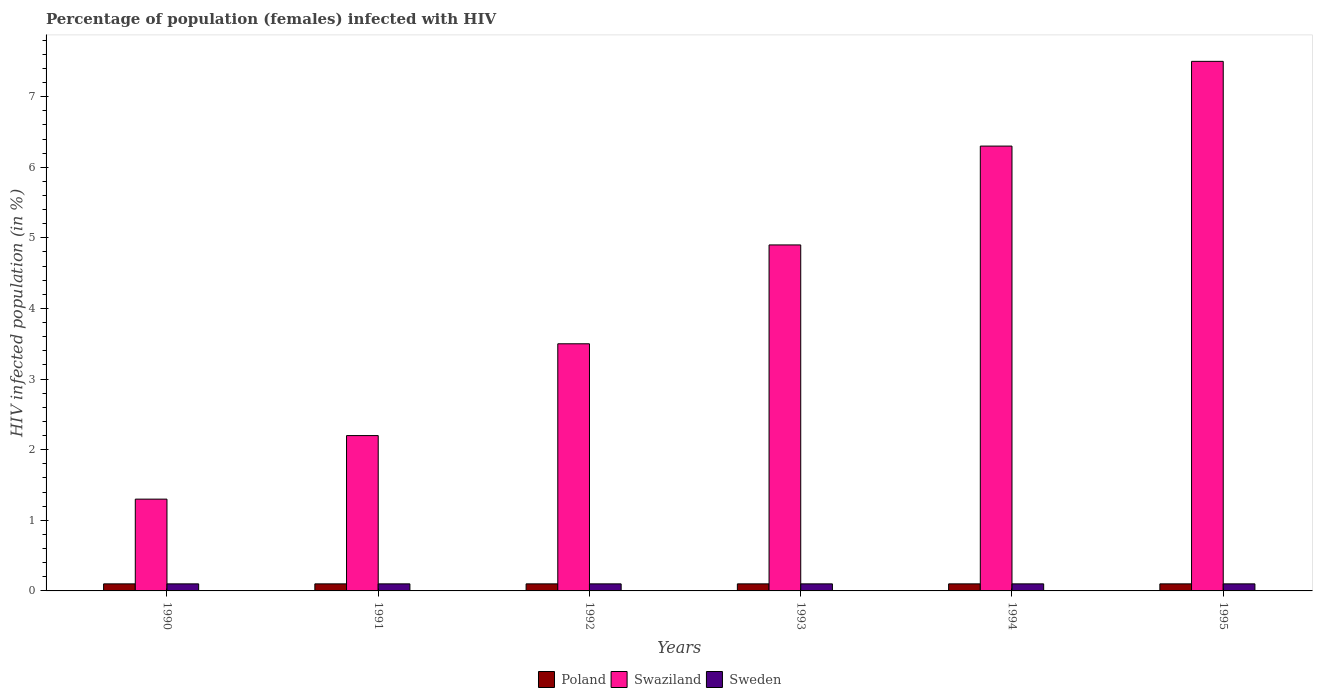How many groups of bars are there?
Give a very brief answer. 6. Are the number of bars per tick equal to the number of legend labels?
Keep it short and to the point. Yes. Are the number of bars on each tick of the X-axis equal?
Offer a very short reply. Yes. How many bars are there on the 1st tick from the left?
Your answer should be very brief. 3. How many bars are there on the 4th tick from the right?
Offer a terse response. 3. What is the label of the 5th group of bars from the left?
Your answer should be very brief. 1994. In how many cases, is the number of bars for a given year not equal to the number of legend labels?
Ensure brevity in your answer.  0. In which year was the percentage of HIV infected female population in Swaziland maximum?
Your answer should be compact. 1995. In which year was the percentage of HIV infected female population in Swaziland minimum?
Ensure brevity in your answer.  1990. What is the total percentage of HIV infected female population in Swaziland in the graph?
Your answer should be compact. 25.7. What is the average percentage of HIV infected female population in Sweden per year?
Provide a succinct answer. 0.1. In the year 1991, what is the difference between the percentage of HIV infected female population in Swaziland and percentage of HIV infected female population in Sweden?
Keep it short and to the point. 2.1. In how many years, is the percentage of HIV infected female population in Sweden greater than 7.6 %?
Offer a terse response. 0. Is the difference between the percentage of HIV infected female population in Swaziland in 1990 and 1992 greater than the difference between the percentage of HIV infected female population in Sweden in 1990 and 1992?
Provide a succinct answer. No. In how many years, is the percentage of HIV infected female population in Poland greater than the average percentage of HIV infected female population in Poland taken over all years?
Provide a short and direct response. 6. Is the sum of the percentage of HIV infected female population in Poland in 1992 and 1993 greater than the maximum percentage of HIV infected female population in Sweden across all years?
Make the answer very short. Yes. What does the 3rd bar from the left in 1992 represents?
Your answer should be compact. Sweden. What does the 3rd bar from the right in 1993 represents?
Provide a short and direct response. Poland. How many bars are there?
Your answer should be compact. 18. What is the difference between two consecutive major ticks on the Y-axis?
Your answer should be compact. 1. Does the graph contain any zero values?
Your answer should be compact. No. How are the legend labels stacked?
Your response must be concise. Horizontal. What is the title of the graph?
Your answer should be very brief. Percentage of population (females) infected with HIV. Does "South Africa" appear as one of the legend labels in the graph?
Keep it short and to the point. No. What is the label or title of the X-axis?
Offer a terse response. Years. What is the label or title of the Y-axis?
Offer a very short reply. HIV infected population (in %). What is the HIV infected population (in %) in Poland in 1990?
Your response must be concise. 0.1. What is the HIV infected population (in %) of Sweden in 1990?
Provide a short and direct response. 0.1. What is the HIV infected population (in %) in Poland in 1991?
Your response must be concise. 0.1. What is the HIV infected population (in %) in Sweden in 1991?
Your answer should be very brief. 0.1. What is the HIV infected population (in %) of Swaziland in 1992?
Ensure brevity in your answer.  3.5. What is the HIV infected population (in %) in Poland in 1993?
Provide a short and direct response. 0.1. What is the HIV infected population (in %) of Swaziland in 1993?
Give a very brief answer. 4.9. What is the HIV infected population (in %) of Sweden in 1993?
Your answer should be very brief. 0.1. What is the HIV infected population (in %) in Swaziland in 1994?
Provide a short and direct response. 6.3. Across all years, what is the maximum HIV infected population (in %) in Swaziland?
Give a very brief answer. 7.5. Across all years, what is the minimum HIV infected population (in %) of Swaziland?
Give a very brief answer. 1.3. Across all years, what is the minimum HIV infected population (in %) of Sweden?
Provide a succinct answer. 0.1. What is the total HIV infected population (in %) of Swaziland in the graph?
Provide a succinct answer. 25.7. What is the difference between the HIV infected population (in %) in Swaziland in 1990 and that in 1991?
Provide a succinct answer. -0.9. What is the difference between the HIV infected population (in %) in Sweden in 1990 and that in 1991?
Give a very brief answer. 0. What is the difference between the HIV infected population (in %) of Poland in 1990 and that in 1992?
Provide a succinct answer. 0. What is the difference between the HIV infected population (in %) of Sweden in 1990 and that in 1992?
Your answer should be very brief. 0. What is the difference between the HIV infected population (in %) of Swaziland in 1990 and that in 1993?
Keep it short and to the point. -3.6. What is the difference between the HIV infected population (in %) in Sweden in 1990 and that in 1993?
Your answer should be very brief. 0. What is the difference between the HIV infected population (in %) in Poland in 1990 and that in 1994?
Provide a succinct answer. 0. What is the difference between the HIV infected population (in %) in Sweden in 1990 and that in 1994?
Give a very brief answer. 0. What is the difference between the HIV infected population (in %) of Poland in 1990 and that in 1995?
Your answer should be very brief. 0. What is the difference between the HIV infected population (in %) in Swaziland in 1990 and that in 1995?
Give a very brief answer. -6.2. What is the difference between the HIV infected population (in %) of Swaziland in 1991 and that in 1992?
Keep it short and to the point. -1.3. What is the difference between the HIV infected population (in %) of Poland in 1991 and that in 1993?
Ensure brevity in your answer.  0. What is the difference between the HIV infected population (in %) of Sweden in 1991 and that in 1993?
Give a very brief answer. 0. What is the difference between the HIV infected population (in %) in Poland in 1991 and that in 1994?
Provide a succinct answer. 0. What is the difference between the HIV infected population (in %) in Sweden in 1991 and that in 1994?
Offer a terse response. 0. What is the difference between the HIV infected population (in %) of Poland in 1991 and that in 1995?
Keep it short and to the point. 0. What is the difference between the HIV infected population (in %) of Poland in 1992 and that in 1993?
Your response must be concise. 0. What is the difference between the HIV infected population (in %) in Poland in 1992 and that in 1994?
Provide a succinct answer. 0. What is the difference between the HIV infected population (in %) of Swaziland in 1992 and that in 1994?
Provide a short and direct response. -2.8. What is the difference between the HIV infected population (in %) in Sweden in 1992 and that in 1994?
Offer a terse response. 0. What is the difference between the HIV infected population (in %) in Poland in 1992 and that in 1995?
Offer a terse response. 0. What is the difference between the HIV infected population (in %) in Poland in 1993 and that in 1994?
Make the answer very short. 0. What is the difference between the HIV infected population (in %) in Swaziland in 1994 and that in 1995?
Your answer should be compact. -1.2. What is the difference between the HIV infected population (in %) of Poland in 1990 and the HIV infected population (in %) of Sweden in 1992?
Offer a very short reply. 0. What is the difference between the HIV infected population (in %) of Poland in 1990 and the HIV infected population (in %) of Sweden in 1993?
Give a very brief answer. 0. What is the difference between the HIV infected population (in %) of Poland in 1990 and the HIV infected population (in %) of Swaziland in 1994?
Your answer should be compact. -6.2. What is the difference between the HIV infected population (in %) in Swaziland in 1990 and the HIV infected population (in %) in Sweden in 1994?
Give a very brief answer. 1.2. What is the difference between the HIV infected population (in %) in Poland in 1990 and the HIV infected population (in %) in Swaziland in 1995?
Make the answer very short. -7.4. What is the difference between the HIV infected population (in %) in Poland in 1990 and the HIV infected population (in %) in Sweden in 1995?
Provide a succinct answer. 0. What is the difference between the HIV infected population (in %) in Poland in 1991 and the HIV infected population (in %) in Swaziland in 1993?
Provide a succinct answer. -4.8. What is the difference between the HIV infected population (in %) of Poland in 1991 and the HIV infected population (in %) of Sweden in 1993?
Provide a succinct answer. 0. What is the difference between the HIV infected population (in %) of Poland in 1991 and the HIV infected population (in %) of Swaziland in 1994?
Your response must be concise. -6.2. What is the difference between the HIV infected population (in %) in Poland in 1991 and the HIV infected population (in %) in Sweden in 1994?
Offer a terse response. 0. What is the difference between the HIV infected population (in %) of Swaziland in 1991 and the HIV infected population (in %) of Sweden in 1994?
Your answer should be very brief. 2.1. What is the difference between the HIV infected population (in %) of Poland in 1991 and the HIV infected population (in %) of Sweden in 1995?
Your answer should be compact. 0. What is the difference between the HIV infected population (in %) of Poland in 1992 and the HIV infected population (in %) of Swaziland in 1993?
Give a very brief answer. -4.8. What is the difference between the HIV infected population (in %) of Poland in 1992 and the HIV infected population (in %) of Sweden in 1995?
Offer a very short reply. 0. What is the difference between the HIV infected population (in %) of Poland in 1993 and the HIV infected population (in %) of Swaziland in 1994?
Offer a very short reply. -6.2. What is the difference between the HIV infected population (in %) of Poland in 1993 and the HIV infected population (in %) of Sweden in 1994?
Your response must be concise. 0. What is the difference between the HIV infected population (in %) of Poland in 1993 and the HIV infected population (in %) of Swaziland in 1995?
Provide a succinct answer. -7.4. What is the difference between the HIV infected population (in %) in Poland in 1993 and the HIV infected population (in %) in Sweden in 1995?
Your answer should be compact. 0. What is the difference between the HIV infected population (in %) of Poland in 1994 and the HIV infected population (in %) of Swaziland in 1995?
Your answer should be compact. -7.4. What is the difference between the HIV infected population (in %) of Poland in 1994 and the HIV infected population (in %) of Sweden in 1995?
Give a very brief answer. 0. What is the difference between the HIV infected population (in %) in Swaziland in 1994 and the HIV infected population (in %) in Sweden in 1995?
Offer a very short reply. 6.2. What is the average HIV infected population (in %) of Swaziland per year?
Your answer should be compact. 4.28. What is the average HIV infected population (in %) in Sweden per year?
Make the answer very short. 0.1. In the year 1990, what is the difference between the HIV infected population (in %) in Swaziland and HIV infected population (in %) in Sweden?
Keep it short and to the point. 1.2. In the year 1991, what is the difference between the HIV infected population (in %) in Poland and HIV infected population (in %) in Sweden?
Your answer should be very brief. 0. In the year 1993, what is the difference between the HIV infected population (in %) of Poland and HIV infected population (in %) of Swaziland?
Offer a terse response. -4.8. In the year 1994, what is the difference between the HIV infected population (in %) in Poland and HIV infected population (in %) in Swaziland?
Make the answer very short. -6.2. In the year 1994, what is the difference between the HIV infected population (in %) in Poland and HIV infected population (in %) in Sweden?
Your answer should be very brief. 0. In the year 1995, what is the difference between the HIV infected population (in %) of Poland and HIV infected population (in %) of Sweden?
Your answer should be compact. 0. In the year 1995, what is the difference between the HIV infected population (in %) of Swaziland and HIV infected population (in %) of Sweden?
Your answer should be compact. 7.4. What is the ratio of the HIV infected population (in %) in Swaziland in 1990 to that in 1991?
Provide a succinct answer. 0.59. What is the ratio of the HIV infected population (in %) in Sweden in 1990 to that in 1991?
Your answer should be compact. 1. What is the ratio of the HIV infected population (in %) of Poland in 1990 to that in 1992?
Your answer should be very brief. 1. What is the ratio of the HIV infected population (in %) of Swaziland in 1990 to that in 1992?
Your response must be concise. 0.37. What is the ratio of the HIV infected population (in %) of Sweden in 1990 to that in 1992?
Provide a succinct answer. 1. What is the ratio of the HIV infected population (in %) in Poland in 1990 to that in 1993?
Give a very brief answer. 1. What is the ratio of the HIV infected population (in %) in Swaziland in 1990 to that in 1993?
Make the answer very short. 0.27. What is the ratio of the HIV infected population (in %) in Swaziland in 1990 to that in 1994?
Give a very brief answer. 0.21. What is the ratio of the HIV infected population (in %) of Sweden in 1990 to that in 1994?
Provide a succinct answer. 1. What is the ratio of the HIV infected population (in %) in Poland in 1990 to that in 1995?
Provide a succinct answer. 1. What is the ratio of the HIV infected population (in %) of Swaziland in 1990 to that in 1995?
Make the answer very short. 0.17. What is the ratio of the HIV infected population (in %) in Poland in 1991 to that in 1992?
Provide a succinct answer. 1. What is the ratio of the HIV infected population (in %) in Swaziland in 1991 to that in 1992?
Your answer should be very brief. 0.63. What is the ratio of the HIV infected population (in %) in Poland in 1991 to that in 1993?
Your response must be concise. 1. What is the ratio of the HIV infected population (in %) in Swaziland in 1991 to that in 1993?
Provide a short and direct response. 0.45. What is the ratio of the HIV infected population (in %) in Sweden in 1991 to that in 1993?
Make the answer very short. 1. What is the ratio of the HIV infected population (in %) in Poland in 1991 to that in 1994?
Offer a terse response. 1. What is the ratio of the HIV infected population (in %) in Swaziland in 1991 to that in 1994?
Ensure brevity in your answer.  0.35. What is the ratio of the HIV infected population (in %) of Sweden in 1991 to that in 1994?
Provide a succinct answer. 1. What is the ratio of the HIV infected population (in %) of Poland in 1991 to that in 1995?
Your answer should be very brief. 1. What is the ratio of the HIV infected population (in %) in Swaziland in 1991 to that in 1995?
Keep it short and to the point. 0.29. What is the ratio of the HIV infected population (in %) of Sweden in 1991 to that in 1995?
Provide a short and direct response. 1. What is the ratio of the HIV infected population (in %) of Poland in 1992 to that in 1993?
Offer a very short reply. 1. What is the ratio of the HIV infected population (in %) of Sweden in 1992 to that in 1993?
Give a very brief answer. 1. What is the ratio of the HIV infected population (in %) of Swaziland in 1992 to that in 1994?
Offer a terse response. 0.56. What is the ratio of the HIV infected population (in %) in Swaziland in 1992 to that in 1995?
Offer a very short reply. 0.47. What is the ratio of the HIV infected population (in %) of Poland in 1993 to that in 1994?
Offer a terse response. 1. What is the ratio of the HIV infected population (in %) in Sweden in 1993 to that in 1994?
Your answer should be very brief. 1. What is the ratio of the HIV infected population (in %) of Swaziland in 1993 to that in 1995?
Ensure brevity in your answer.  0.65. What is the ratio of the HIV infected population (in %) of Swaziland in 1994 to that in 1995?
Offer a terse response. 0.84. What is the ratio of the HIV infected population (in %) in Sweden in 1994 to that in 1995?
Your answer should be compact. 1. What is the difference between the highest and the second highest HIV infected population (in %) of Poland?
Offer a terse response. 0. What is the difference between the highest and the second highest HIV infected population (in %) in Swaziland?
Offer a terse response. 1.2. What is the difference between the highest and the lowest HIV infected population (in %) in Poland?
Provide a succinct answer. 0. What is the difference between the highest and the lowest HIV infected population (in %) in Sweden?
Your answer should be compact. 0. 